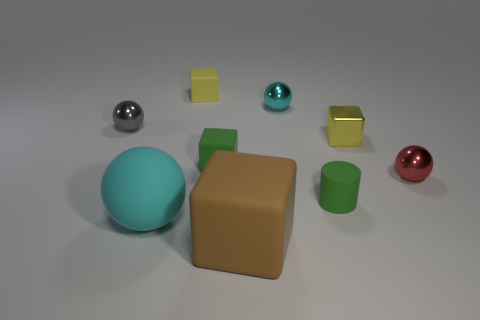Subtract 1 blocks. How many blocks are left? 3 Subtract all cyan cubes. Subtract all yellow spheres. How many cubes are left? 4 Subtract all cylinders. How many objects are left? 8 Subtract all brown cubes. Subtract all small purple matte things. How many objects are left? 8 Add 3 tiny green objects. How many tiny green objects are left? 5 Add 3 tiny gray metallic objects. How many tiny gray metallic objects exist? 4 Subtract 1 cyan spheres. How many objects are left? 8 